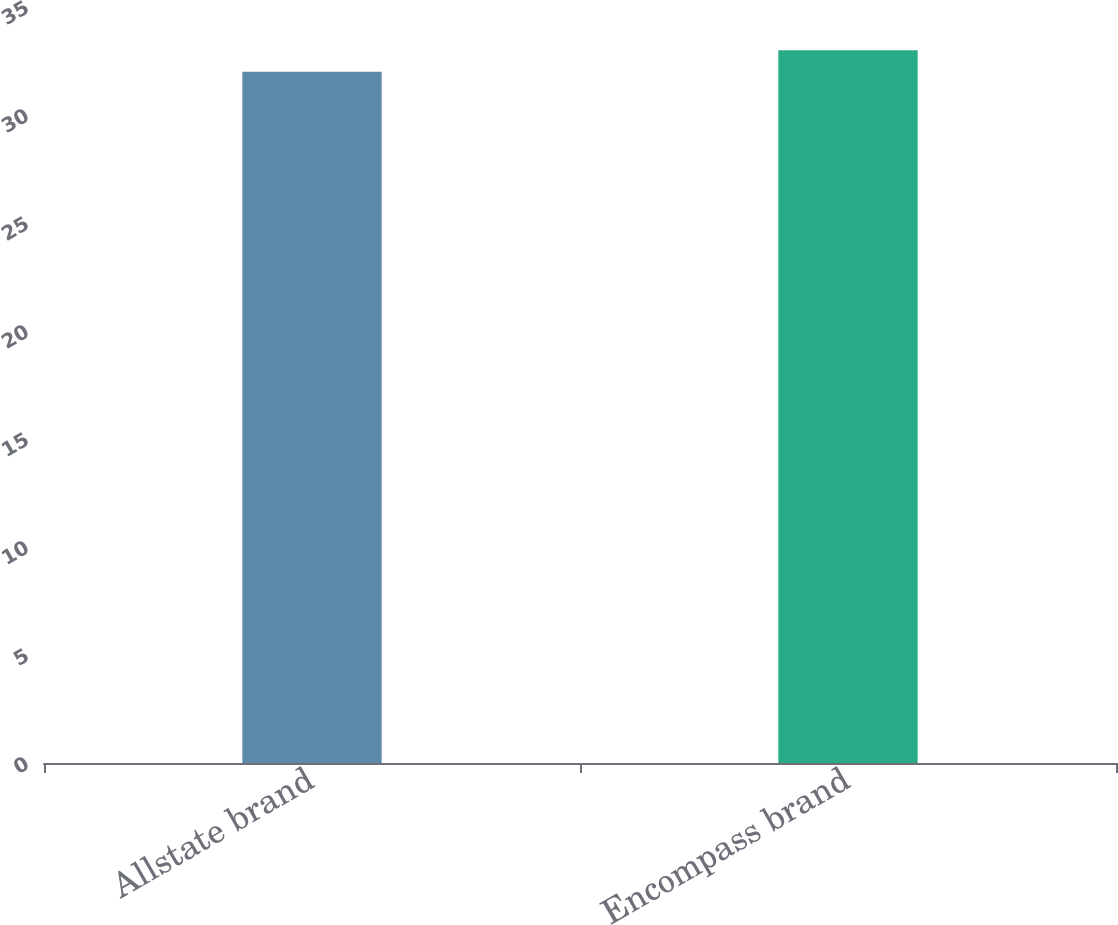Convert chart to OTSL. <chart><loc_0><loc_0><loc_500><loc_500><bar_chart><fcel>Allstate brand<fcel>Encompass brand<nl><fcel>32<fcel>33<nl></chart> 